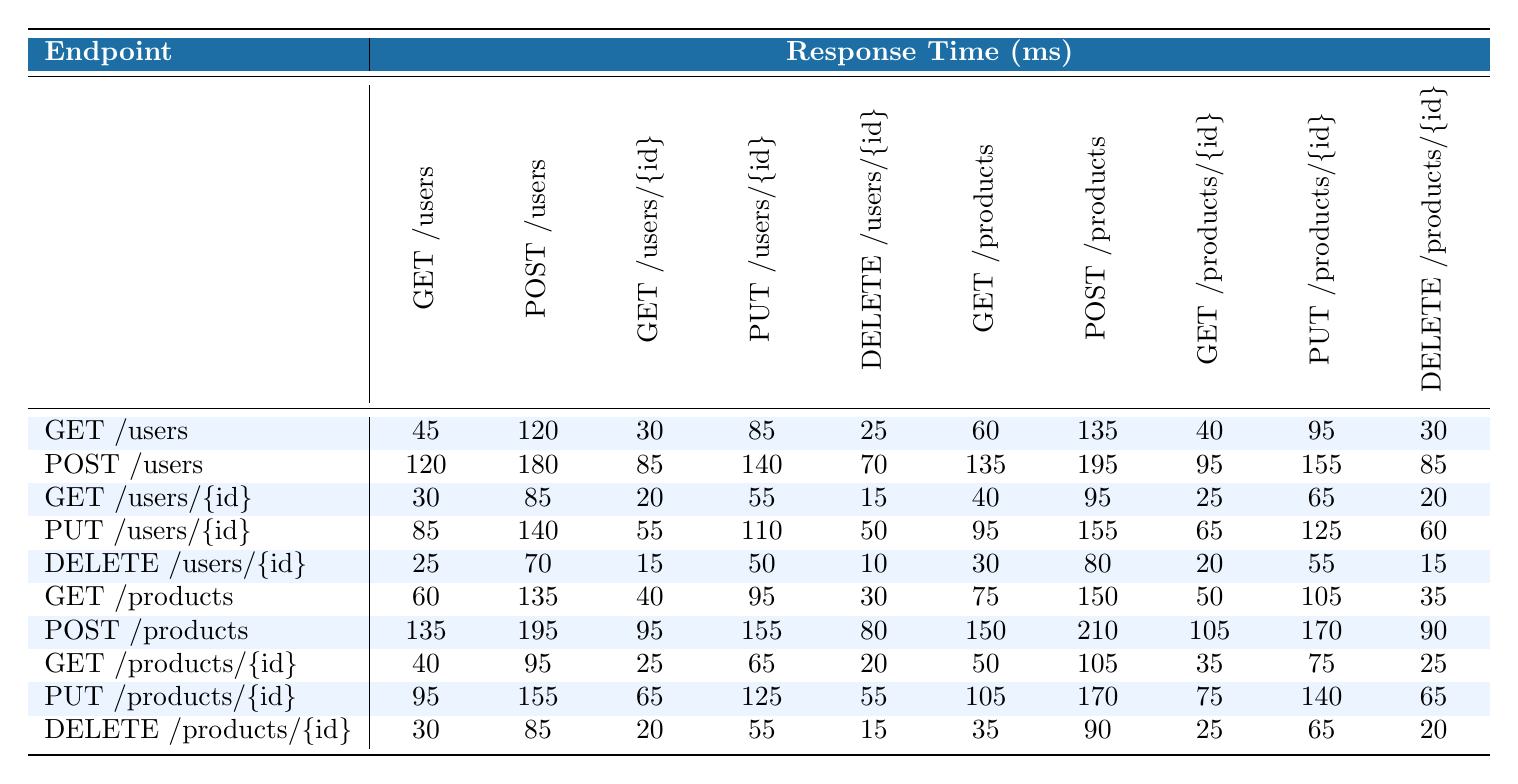What is the response time for the GET /users endpoint when using POST /products? The response time for the GET /users endpoint when using POST /products is located in the intersection of the corresponding row and column in the table. This value is 135 ms.
Answer: 135 ms Which endpoint has the longest average response time? To find the endpoint with the longest average response time, calculate the average for each endpoint. The averages are as follows: GET /users (65 ms), POST /users (136 ms), GET /users/{id} (31 ms), PUT /users/{id} (86 ms), DELETE /users/{id} (33 ms), GET /products (75 ms), POST /products (162 ms), GET /products/{id} (40 ms), PUT /products/{id} (105 ms), DELETE /products/{id} (42 ms). The endpoint with the longest average is POST /products at 162 ms.
Answer: POST /products Is the response time for DELETE /products/{id} less than that for GET /products/{id}? Looking at the table, for DELETE /products/{id}, the response time is consistently 20 ms, while for GET /products/{id}, it is 25 ms. Since 20 ms is less than 25 ms, the statement is true.
Answer: Yes What is the difference between the response time for PUT /users/{id} and GET /products? To answer, find the response times: for PUT /users/{id}, the value at the intersection with itself is 110 ms; for GET /products, the intersection is also 75 ms. The difference is 110 ms - 75 ms = 35 ms.
Answer: 35 ms What is the median response time for the POST /users endpoint? First, list the response times for POST /users: [120, 180, 85, 140, 70, 135, 195, 95, 155, 85]. Sort these values to get [70, 85, 85, 95, 120, 135, 140, 155, 180, 195]. The median is the average of the 5th and 6th values: (120 + 135) / 2 = 127.5 ms.
Answer: 127.5 ms Which two endpoints have the closest response times for the GET /products endpoint? The response times for GET /products are [60, 135, 40, 95, 30, 75, 150, 50, 105, 35]. To find the closest, compare each value: the response time of 75 ms for GET /products and 70 ms for POST /products is fairly close, with a difference of only 5 ms. Therefore, these two endpoints have the closest times.
Answer: GET /products and POST /products Is the response time for POST /products ever less than 150 ms? The response times for POST /products are [135, 195, 95, 155, 80, 150, 210, 105, 170, 90]. Since there are multiple values less than 150 ms (specifically 135, 95, 80, 105, and 90), the statement is true.
Answer: Yes What is the total response time for DELETE operations across all endpoints? The response times for DELETE operations are 25 ms (DELETE /users/{id}), 15 ms (DELETE /products/{id}), totaling 25 + 15 = 40 ms.
Answer: 40 ms Which endpoint has the highest individual response time recorded? The highest individual response time can be found in the table by inspecting each response time. The maximum value is 210 ms for POST /products.
Answer: POST /products What is the response time for GET /users/{id} compared to that of DELETE /users/{id}? The response time for GET /users/{id} is 20 ms, while for DELETE /users/{id} it is 15 ms. Thus, 20 ms is greater than 15 ms.
Answer: Yes, it is greater 